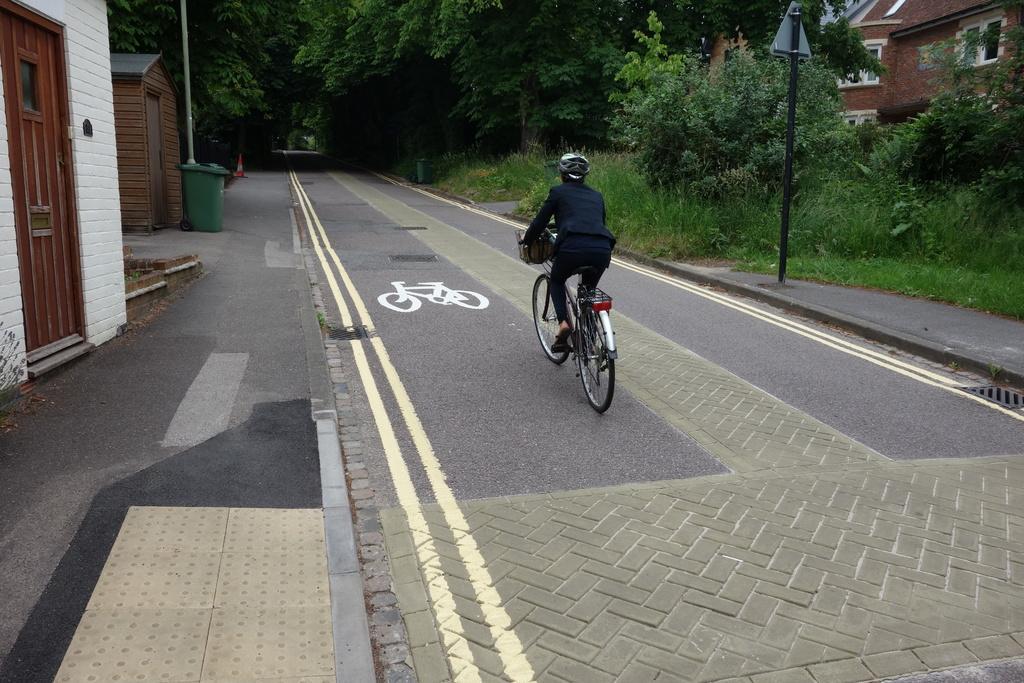How would you summarize this image in a sentence or two? In this image I can see a person riding a bicycle on the road. I can see few buildings. There are few trees. 